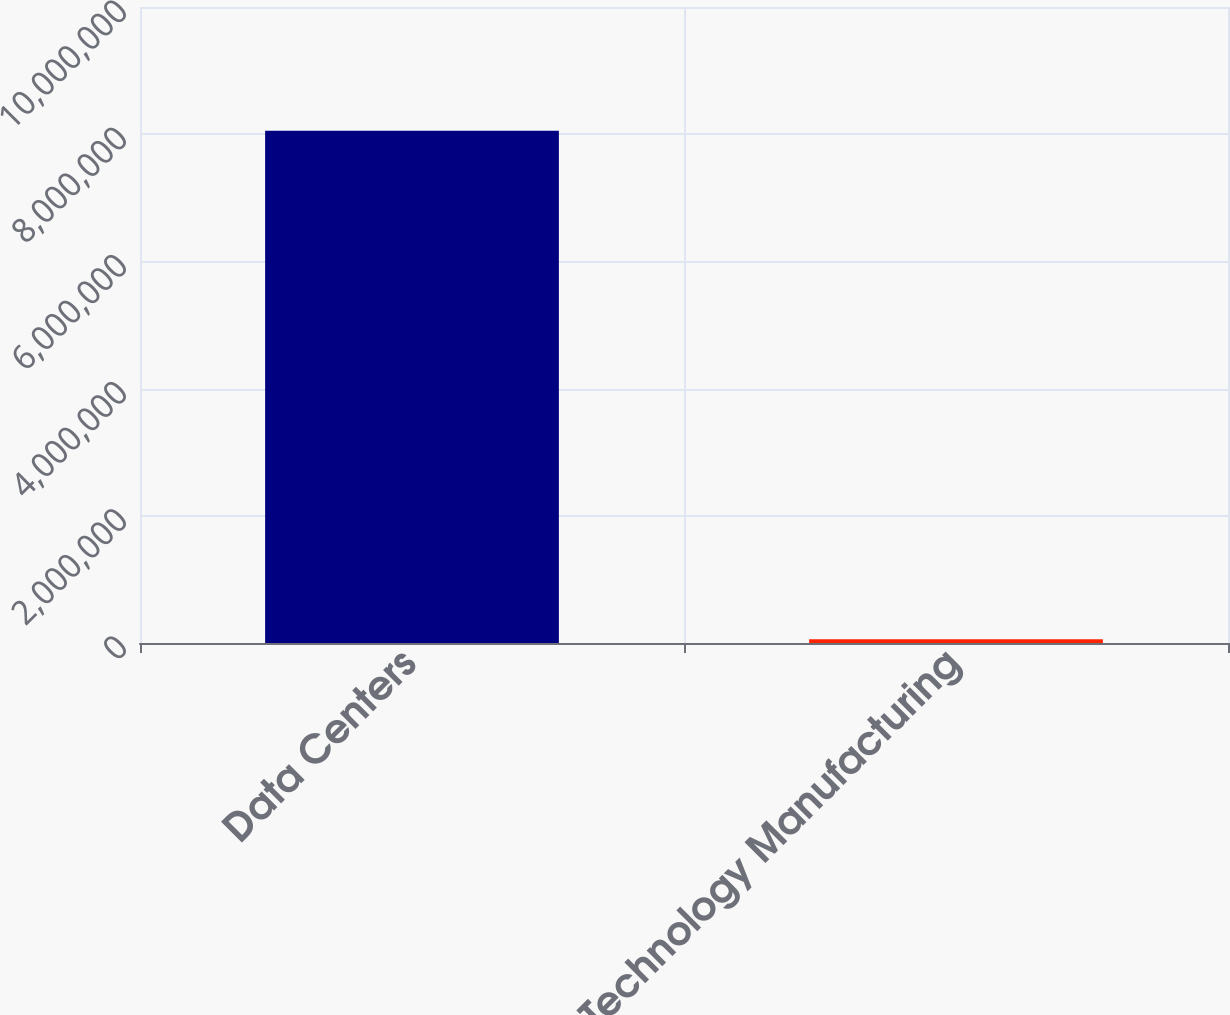Convert chart to OTSL. <chart><loc_0><loc_0><loc_500><loc_500><bar_chart><fcel>Data Centers<fcel>Technology Manufacturing<nl><fcel>8.05236e+06<fcel>57766<nl></chart> 